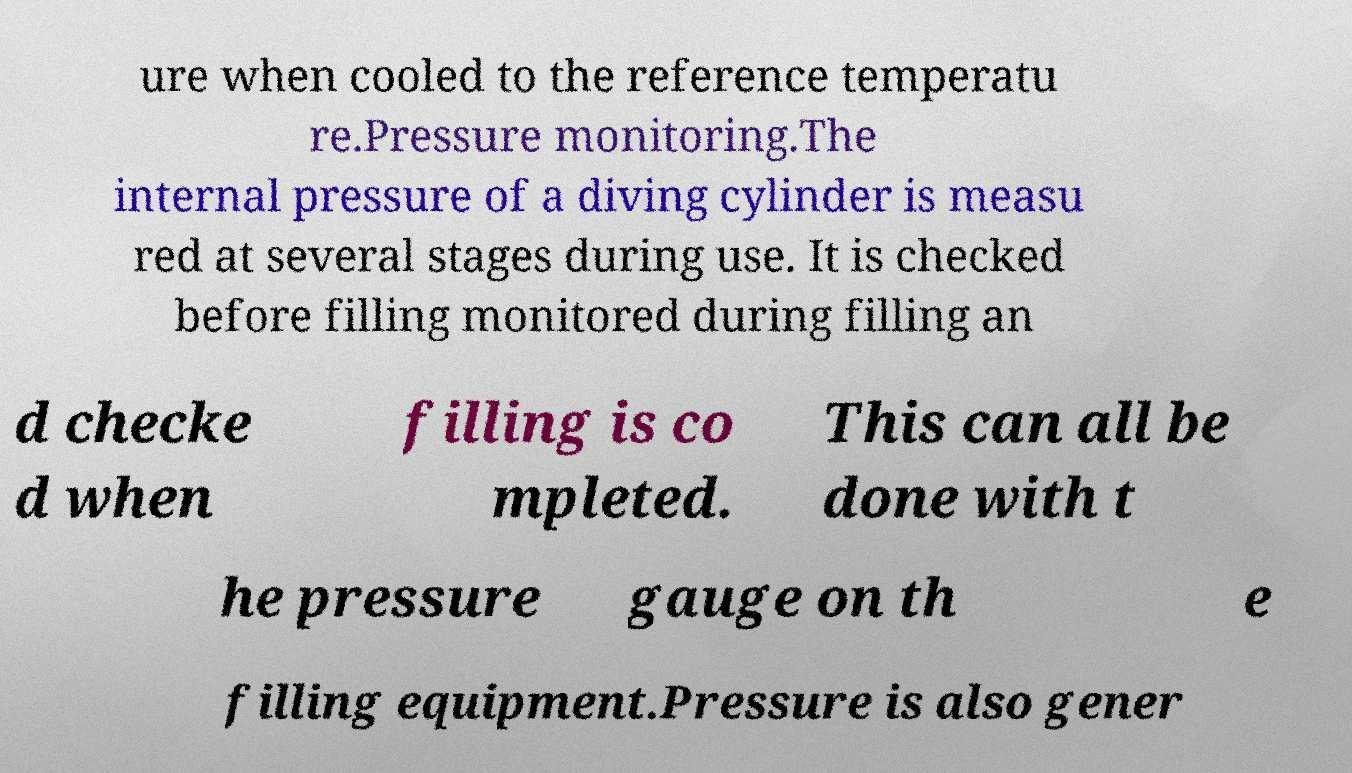Please read and relay the text visible in this image. What does it say? ure when cooled to the reference temperatu re.Pressure monitoring.The internal pressure of a diving cylinder is measu red at several stages during use. It is checked before filling monitored during filling an d checke d when filling is co mpleted. This can all be done with t he pressure gauge on th e filling equipment.Pressure is also gener 